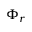Convert formula to latex. <formula><loc_0><loc_0><loc_500><loc_500>\Phi _ { r }</formula> 